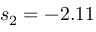Convert formula to latex. <formula><loc_0><loc_0><loc_500><loc_500>s _ { 2 } = - 2 . 1 1</formula> 